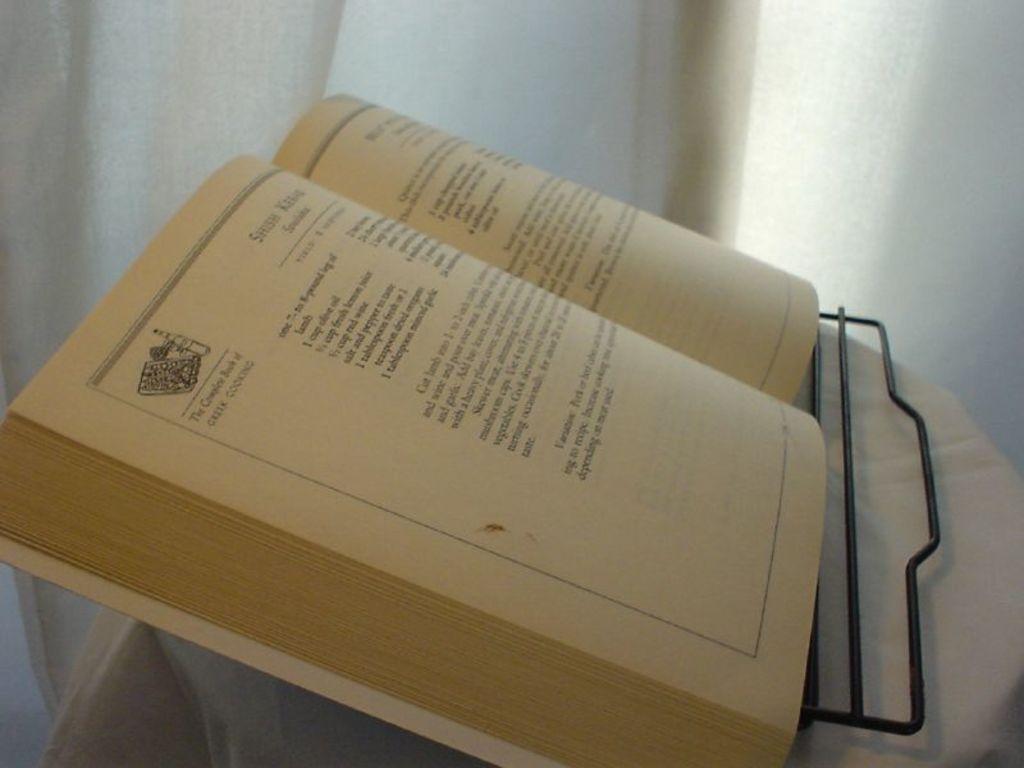What book is this?
Give a very brief answer. Unanswerable. 